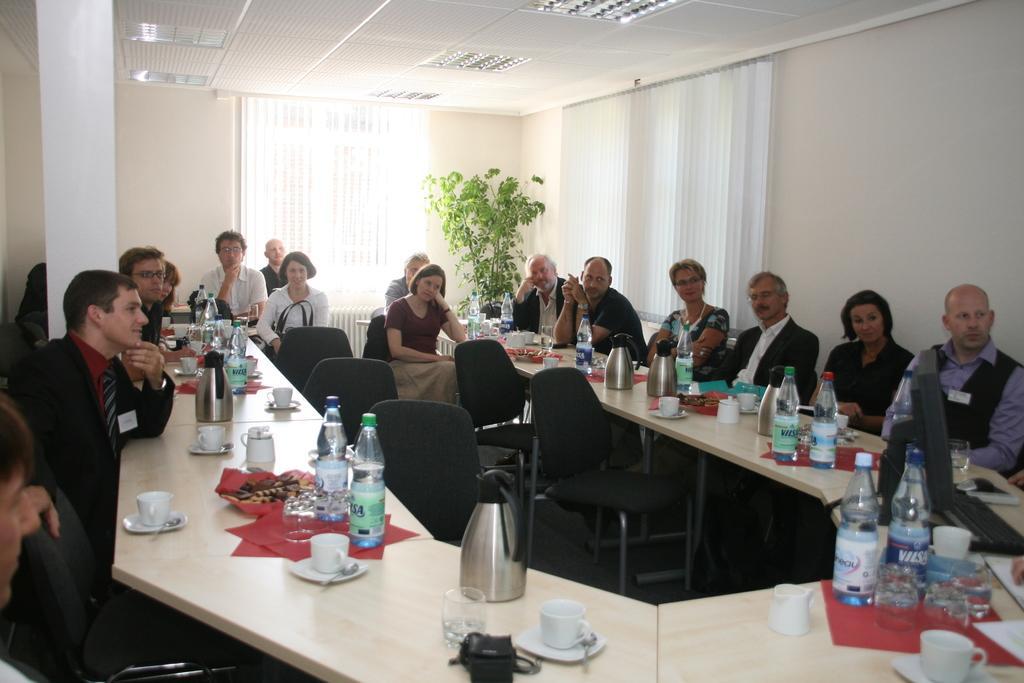In one or two sentences, can you explain what this image depicts? In this picture there is a two rows of people those who are attending the meeting and in between the wooden table, there are five empty chairs and the tea cups, bottles and flasks are placed on the table, there is a plant at the right side of the image and white color curtains behind the ladies, there is a white color ceiling at the top of the roof. 